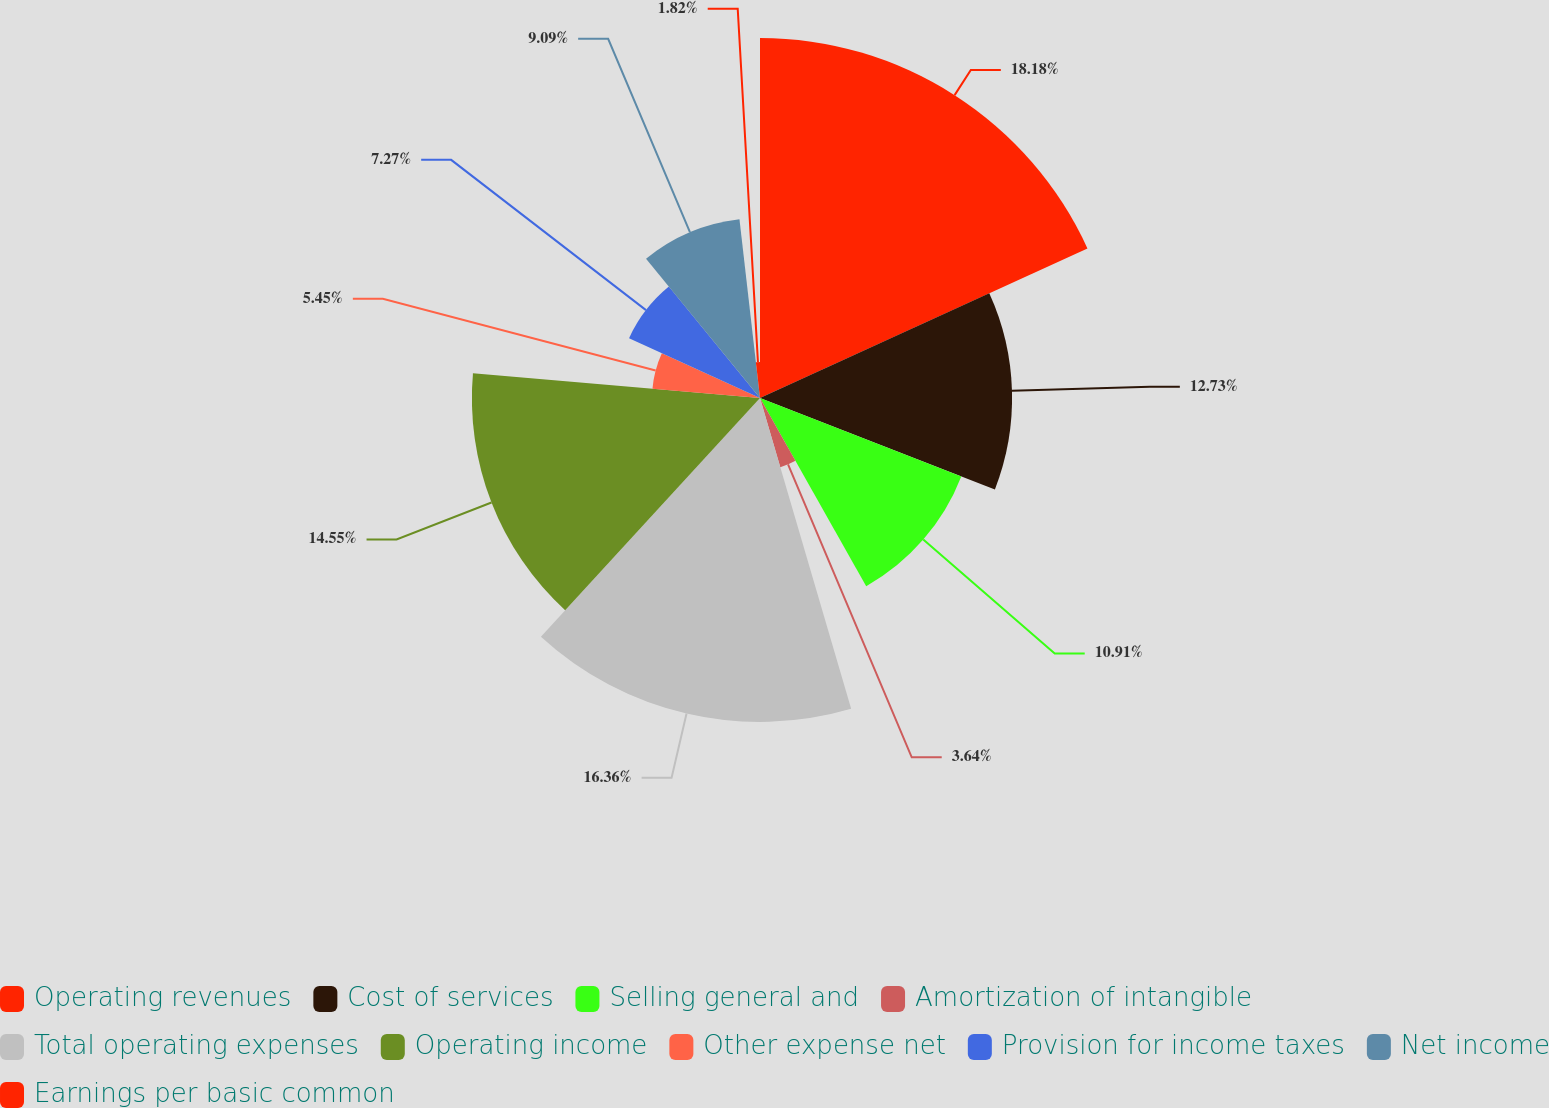Convert chart. <chart><loc_0><loc_0><loc_500><loc_500><pie_chart><fcel>Operating revenues<fcel>Cost of services<fcel>Selling general and<fcel>Amortization of intangible<fcel>Total operating expenses<fcel>Operating income<fcel>Other expense net<fcel>Provision for income taxes<fcel>Net income<fcel>Earnings per basic common<nl><fcel>18.18%<fcel>12.73%<fcel>10.91%<fcel>3.64%<fcel>16.36%<fcel>14.55%<fcel>5.45%<fcel>7.27%<fcel>9.09%<fcel>1.82%<nl></chart> 